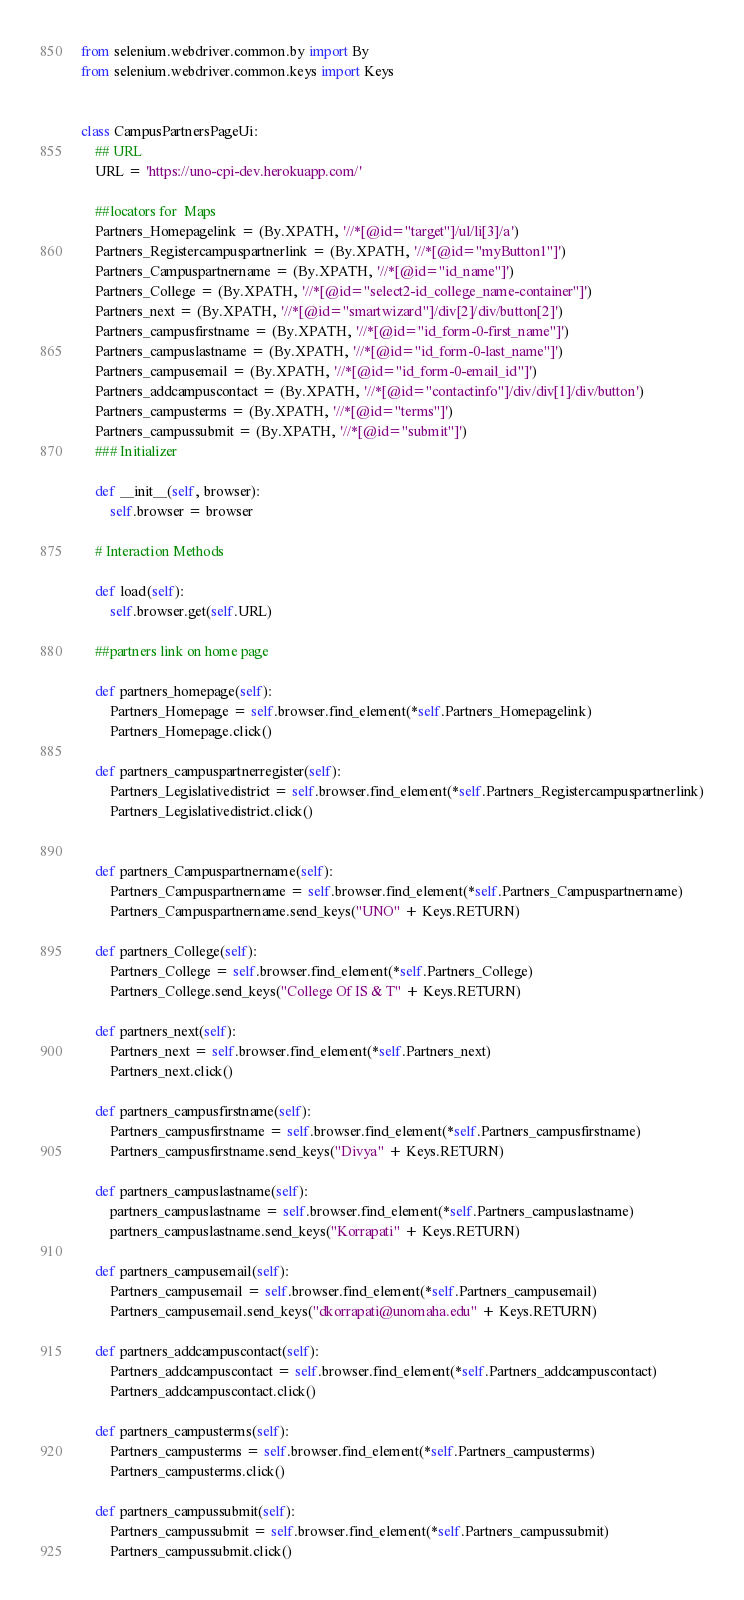Convert code to text. <code><loc_0><loc_0><loc_500><loc_500><_Python_>from selenium.webdriver.common.by import By
from selenium.webdriver.common.keys import Keys


class CampusPartnersPageUi:
    ## URL
    URL = 'https://uno-cpi-dev.herokuapp.com/'

    ##locators for  Maps
    Partners_Homepagelink = (By.XPATH, '//*[@id="target"]/ul/li[3]/a')
    Partners_Registercampuspartnerlink = (By.XPATH, '//*[@id="myButton1"]')
    Partners_Campuspartnername = (By.XPATH, '//*[@id="id_name"]')
    Partners_College = (By.XPATH, '//*[@id="select2-id_college_name-container"]')
    Partners_next = (By.XPATH, '//*[@id="smartwizard"]/div[2]/div/button[2]')
    Partners_campusfirstname = (By.XPATH, '//*[@id="id_form-0-first_name"]')
    Partners_campuslastname = (By.XPATH, '//*[@id="id_form-0-last_name"]')
    Partners_campusemail = (By.XPATH, '//*[@id="id_form-0-email_id"]')
    Partners_addcampuscontact = (By.XPATH, '//*[@id="contactinfo"]/div/div[1]/div/button')
    Partners_campusterms = (By.XPATH, '//*[@id="terms"]')
    Partners_campussubmit = (By.XPATH, '//*[@id="submit"]')
    ### Initializer

    def __init__(self, browser):
        self.browser = browser

    # Interaction Methods

    def load(self):
        self.browser.get(self.URL)

    ##partners link on home page

    def partners_homepage(self):
        Partners_Homepage = self.browser.find_element(*self.Partners_Homepagelink)
        Partners_Homepage.click()

    def partners_campuspartnerregister(self):
        Partners_Legislativedistrict = self.browser.find_element(*self.Partners_Registercampuspartnerlink)
        Partners_Legislativedistrict.click()


    def partners_Campuspartnername(self):
        Partners_Campuspartnername = self.browser.find_element(*self.Partners_Campuspartnername)
        Partners_Campuspartnername.send_keys("UNO" + Keys.RETURN)

    def partners_College(self):
        Partners_College = self.browser.find_element(*self.Partners_College)
        Partners_College.send_keys("College Of IS & T" + Keys.RETURN)

    def partners_next(self):
        Partners_next = self.browser.find_element(*self.Partners_next)
        Partners_next.click()

    def partners_campusfirstname(self):
        Partners_campusfirstname = self.browser.find_element(*self.Partners_campusfirstname)
        Partners_campusfirstname.send_keys("Divya" + Keys.RETURN)

    def partners_campuslastname(self):
        partners_campuslastname = self.browser.find_element(*self.Partners_campuslastname)
        partners_campuslastname.send_keys("Korrapati" + Keys.RETURN)

    def partners_campusemail(self):
        Partners_campusemail = self.browser.find_element(*self.Partners_campusemail)
        Partners_campusemail.send_keys("dkorrapati@unomaha.edu" + Keys.RETURN)

    def partners_addcampuscontact(self):
        Partners_addcampuscontact = self.browser.find_element(*self.Partners_addcampuscontact)
        Partners_addcampuscontact.click()

    def partners_campusterms(self):
        Partners_campusterms = self.browser.find_element(*self.Partners_campusterms)
        Partners_campusterms.click()

    def partners_campussubmit(self):
        Partners_campussubmit = self.browser.find_element(*self.Partners_campussubmit)
        Partners_campussubmit.click()</code> 